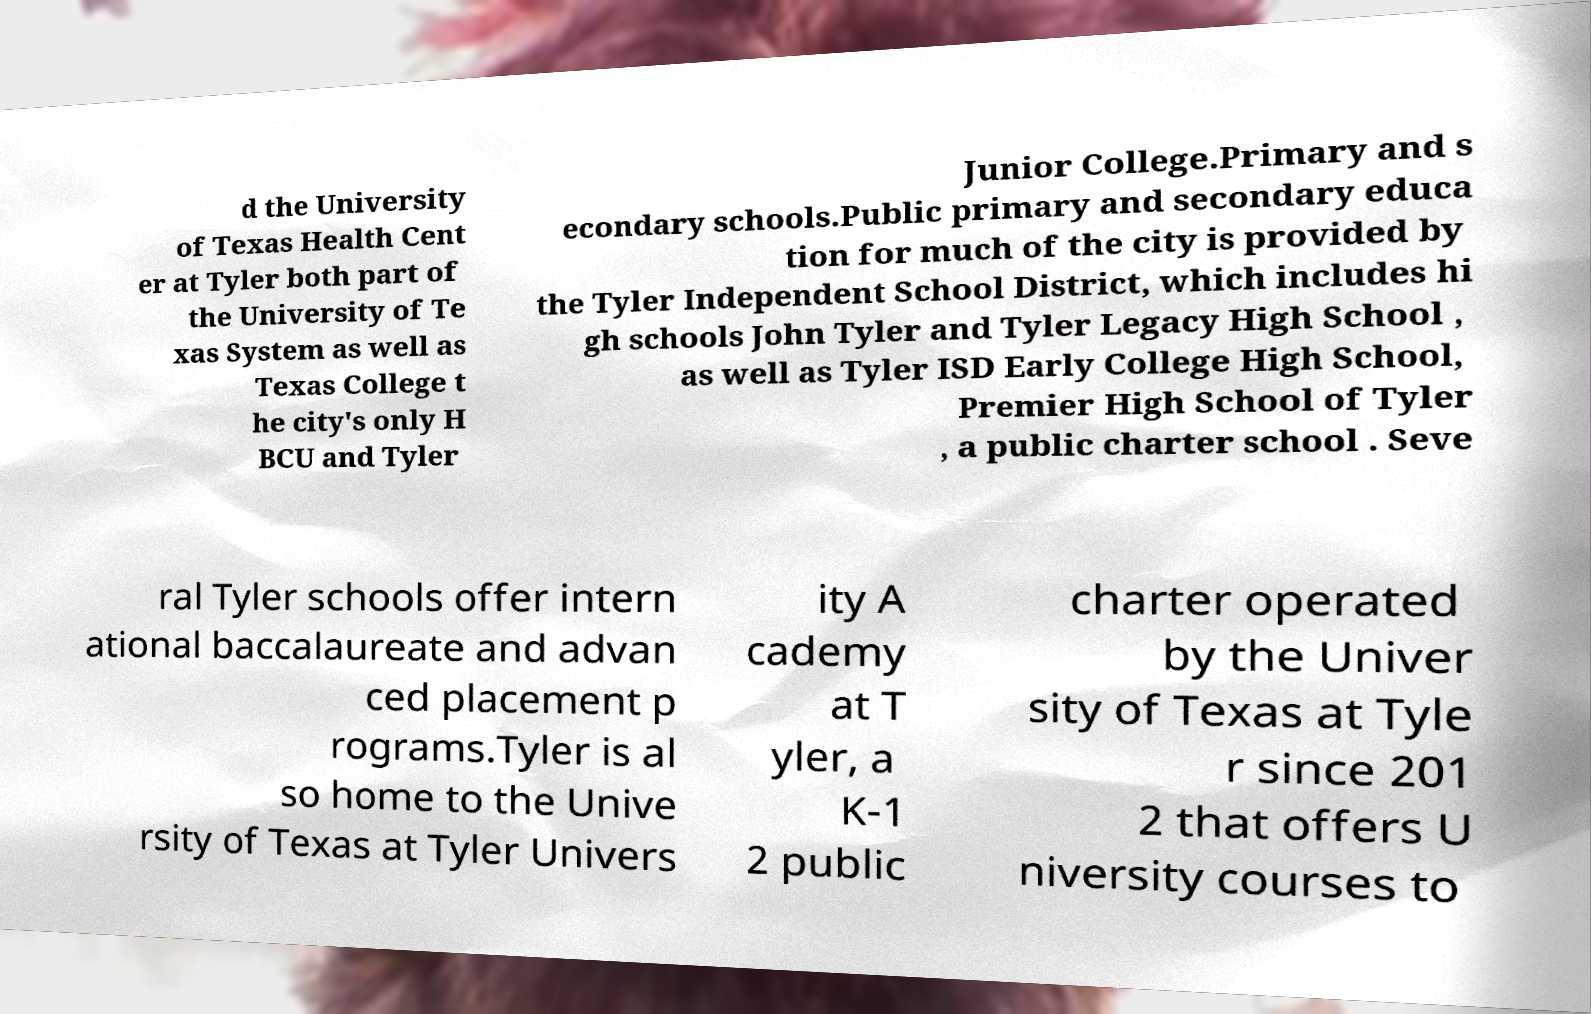Can you read and provide the text displayed in the image?This photo seems to have some interesting text. Can you extract and type it out for me? d the University of Texas Health Cent er at Tyler both part of the University of Te xas System as well as Texas College t he city's only H BCU and Tyler Junior College.Primary and s econdary schools.Public primary and secondary educa tion for much of the city is provided by the Tyler Independent School District, which includes hi gh schools John Tyler and Tyler Legacy High School , as well as Tyler ISD Early College High School, Premier High School of Tyler , a public charter school . Seve ral Tyler schools offer intern ational baccalaureate and advan ced placement p rograms.Tyler is al so home to the Unive rsity of Texas at Tyler Univers ity A cademy at T yler, a K-1 2 public charter operated by the Univer sity of Texas at Tyle r since 201 2 that offers U niversity courses to 